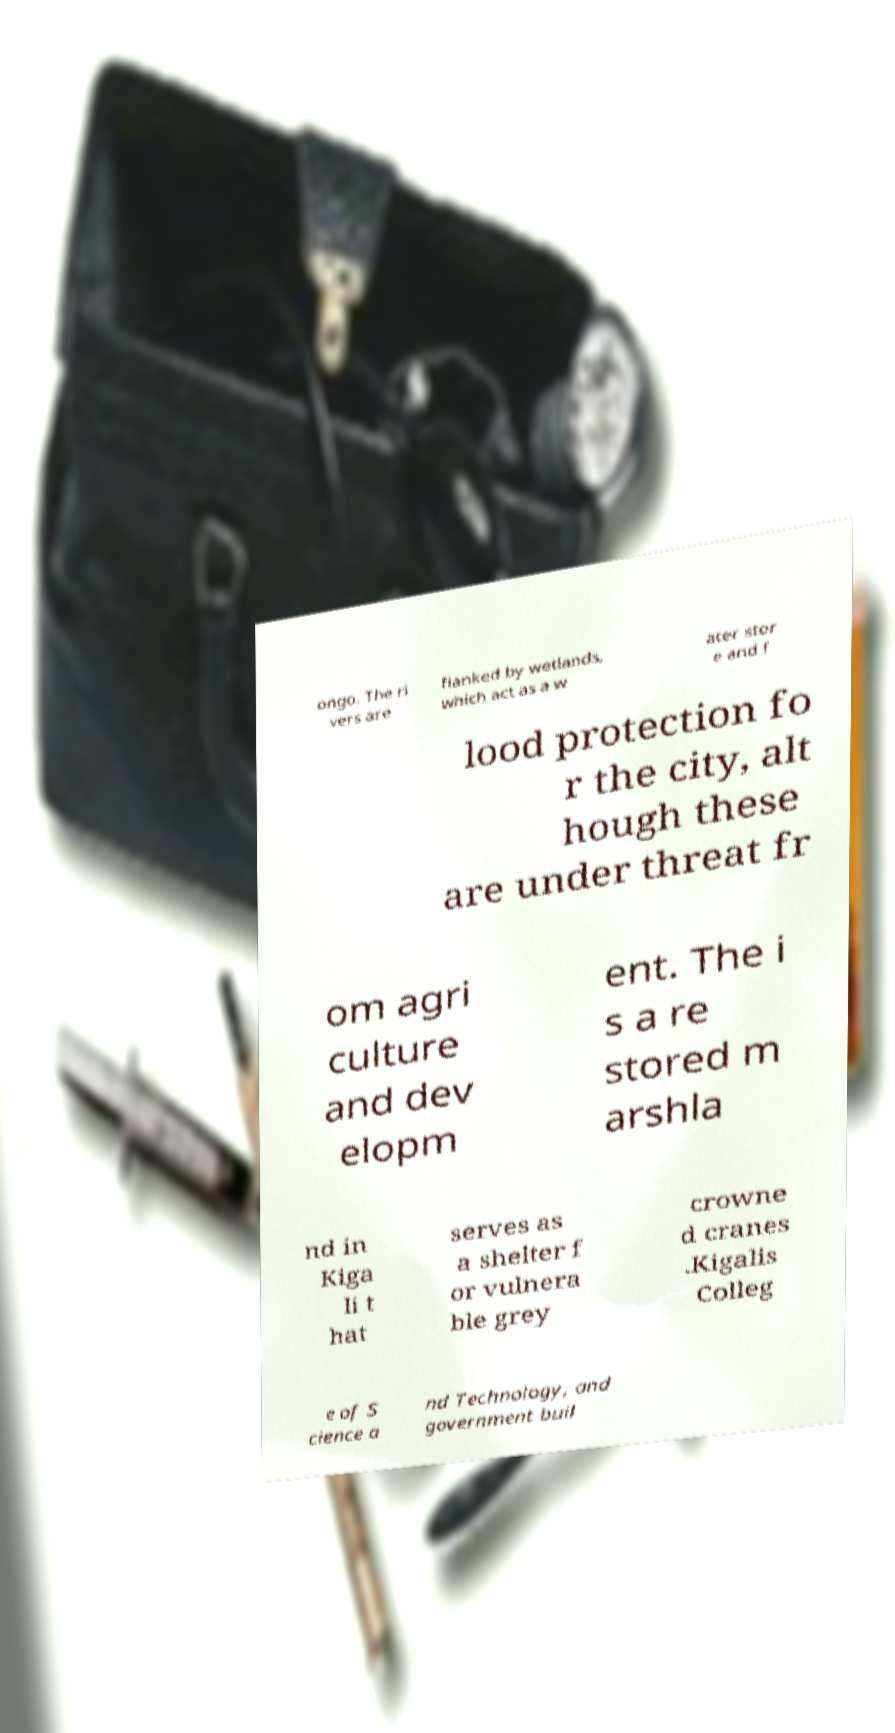For documentation purposes, I need the text within this image transcribed. Could you provide that? ongo. The ri vers are flanked by wetlands, which act as a w ater stor e and f lood protection fo r the city, alt hough these are under threat fr om agri culture and dev elopm ent. The i s a re stored m arshla nd in Kiga li t hat serves as a shelter f or vulnera ble grey crowne d cranes .Kigalis Colleg e of S cience a nd Technology, and government buil 